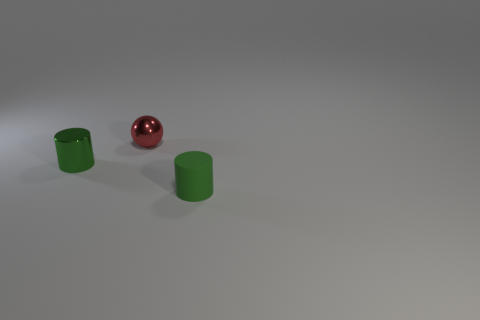Add 1 large purple things. How many objects exist? 4 Subtract all spheres. How many objects are left? 2 Add 1 tiny rubber things. How many tiny rubber things are left? 2 Add 1 large purple objects. How many large purple objects exist? 1 Subtract 0 brown cylinders. How many objects are left? 3 Subtract all rubber objects. Subtract all green things. How many objects are left? 0 